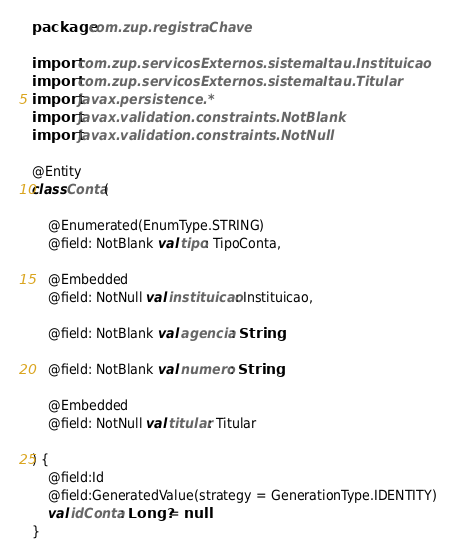<code> <loc_0><loc_0><loc_500><loc_500><_Kotlin_>package com.zup.registraChave

import com.zup.servicosExternos.sistemaItau.Instituicao
import com.zup.servicosExternos.sistemaItau.Titular
import javax.persistence.*
import javax.validation.constraints.NotBlank
import javax.validation.constraints.NotNull

@Entity
class Conta(

    @Enumerated(EnumType.STRING)
    @field: NotBlank val tipo: TipoConta,

    @Embedded
    @field: NotNull val instituicao: Instituicao,

    @field: NotBlank val agencia: String,

    @field: NotBlank val numero: String,

    @Embedded
    @field: NotNull val titular: Titular

) {
    @field:Id
    @field:GeneratedValue(strategy = GenerationType.IDENTITY)
    val idConta: Long? = null
}
</code> 